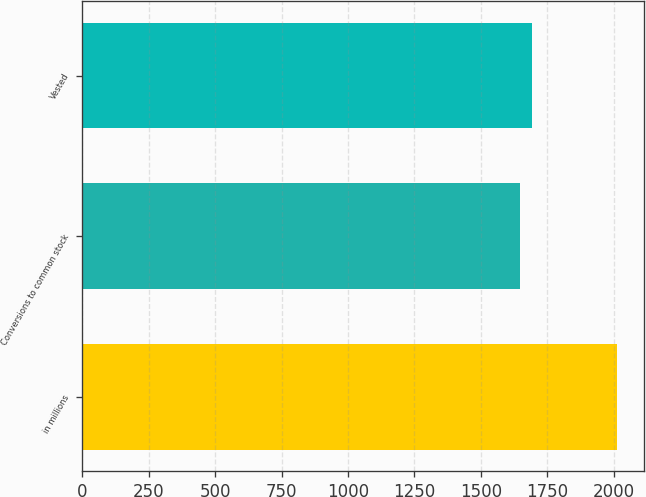<chart> <loc_0><loc_0><loc_500><loc_500><bar_chart><fcel>in millions<fcel>Conversions to common stock<fcel>Vested<nl><fcel>2015<fcel>1646<fcel>1693<nl></chart> 